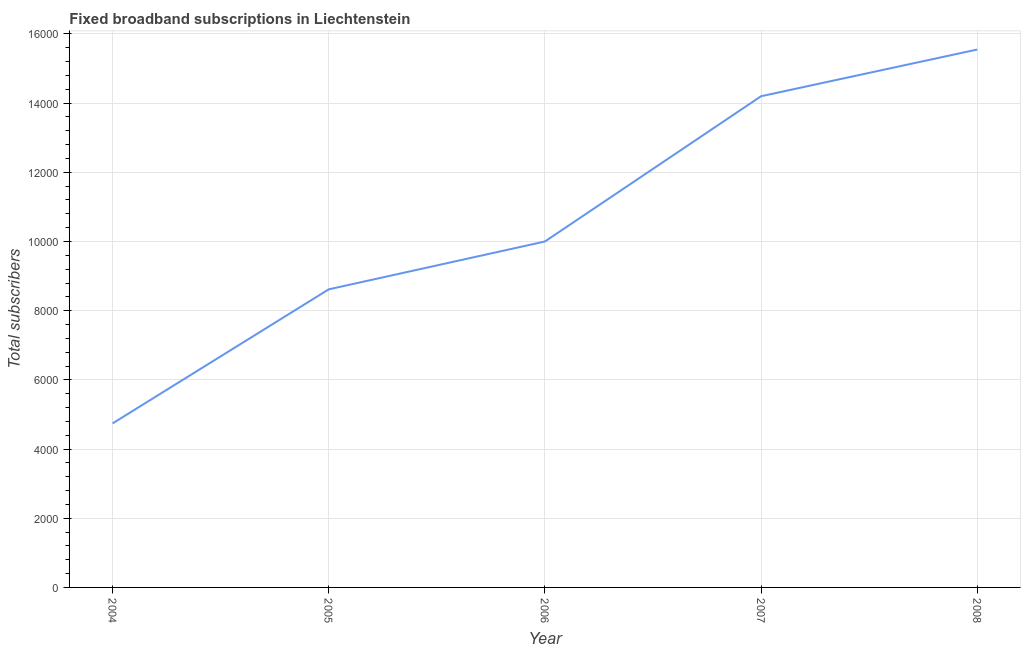What is the total number of fixed broadband subscriptions in 2006?
Make the answer very short. 10000. Across all years, what is the maximum total number of fixed broadband subscriptions?
Your answer should be compact. 1.56e+04. Across all years, what is the minimum total number of fixed broadband subscriptions?
Keep it short and to the point. 4741. What is the sum of the total number of fixed broadband subscriptions?
Give a very brief answer. 5.31e+04. What is the difference between the total number of fixed broadband subscriptions in 2004 and 2007?
Your answer should be compact. -9459. What is the average total number of fixed broadband subscriptions per year?
Your answer should be compact. 1.06e+04. In how many years, is the total number of fixed broadband subscriptions greater than 3200 ?
Offer a terse response. 5. Do a majority of the years between 2007 and 2008 (inclusive) have total number of fixed broadband subscriptions greater than 14800 ?
Offer a very short reply. No. What is the ratio of the total number of fixed broadband subscriptions in 2005 to that in 2007?
Offer a very short reply. 0.61. Is the difference between the total number of fixed broadband subscriptions in 2007 and 2008 greater than the difference between any two years?
Make the answer very short. No. What is the difference between the highest and the second highest total number of fixed broadband subscriptions?
Your answer should be compact. 1350. Is the sum of the total number of fixed broadband subscriptions in 2004 and 2006 greater than the maximum total number of fixed broadband subscriptions across all years?
Your response must be concise. No. What is the difference between the highest and the lowest total number of fixed broadband subscriptions?
Ensure brevity in your answer.  1.08e+04. In how many years, is the total number of fixed broadband subscriptions greater than the average total number of fixed broadband subscriptions taken over all years?
Your answer should be compact. 2. Does the total number of fixed broadband subscriptions monotonically increase over the years?
Your answer should be very brief. Yes. How many lines are there?
Provide a short and direct response. 1. How many years are there in the graph?
Keep it short and to the point. 5. Are the values on the major ticks of Y-axis written in scientific E-notation?
Ensure brevity in your answer.  No. Does the graph contain any zero values?
Your answer should be very brief. No. Does the graph contain grids?
Provide a succinct answer. Yes. What is the title of the graph?
Provide a short and direct response. Fixed broadband subscriptions in Liechtenstein. What is the label or title of the X-axis?
Provide a succinct answer. Year. What is the label or title of the Y-axis?
Give a very brief answer. Total subscribers. What is the Total subscribers of 2004?
Give a very brief answer. 4741. What is the Total subscribers of 2005?
Offer a terse response. 8617. What is the Total subscribers of 2006?
Your response must be concise. 10000. What is the Total subscribers in 2007?
Your response must be concise. 1.42e+04. What is the Total subscribers of 2008?
Your answer should be compact. 1.56e+04. What is the difference between the Total subscribers in 2004 and 2005?
Your response must be concise. -3876. What is the difference between the Total subscribers in 2004 and 2006?
Your response must be concise. -5259. What is the difference between the Total subscribers in 2004 and 2007?
Offer a terse response. -9459. What is the difference between the Total subscribers in 2004 and 2008?
Ensure brevity in your answer.  -1.08e+04. What is the difference between the Total subscribers in 2005 and 2006?
Offer a very short reply. -1383. What is the difference between the Total subscribers in 2005 and 2007?
Offer a terse response. -5583. What is the difference between the Total subscribers in 2005 and 2008?
Your answer should be very brief. -6933. What is the difference between the Total subscribers in 2006 and 2007?
Give a very brief answer. -4200. What is the difference between the Total subscribers in 2006 and 2008?
Offer a terse response. -5550. What is the difference between the Total subscribers in 2007 and 2008?
Provide a short and direct response. -1350. What is the ratio of the Total subscribers in 2004 to that in 2005?
Offer a very short reply. 0.55. What is the ratio of the Total subscribers in 2004 to that in 2006?
Your answer should be compact. 0.47. What is the ratio of the Total subscribers in 2004 to that in 2007?
Offer a terse response. 0.33. What is the ratio of the Total subscribers in 2004 to that in 2008?
Offer a very short reply. 0.3. What is the ratio of the Total subscribers in 2005 to that in 2006?
Offer a terse response. 0.86. What is the ratio of the Total subscribers in 2005 to that in 2007?
Your answer should be compact. 0.61. What is the ratio of the Total subscribers in 2005 to that in 2008?
Keep it short and to the point. 0.55. What is the ratio of the Total subscribers in 2006 to that in 2007?
Provide a short and direct response. 0.7. What is the ratio of the Total subscribers in 2006 to that in 2008?
Keep it short and to the point. 0.64. 